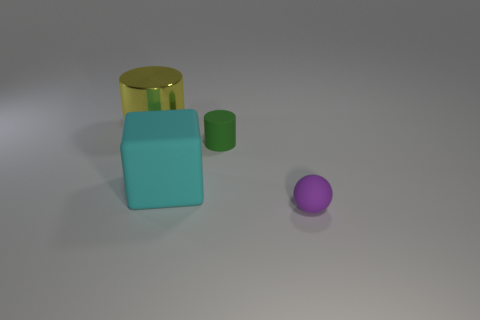What might be the purpose of this collection of objects? This collection of objects may be used to illustrate various geometric shapes, like a cylinder, cube, and sphere, as well as different surface textures and colors for educational or demonstrative purposes in a graphical render or a simple composition study. 